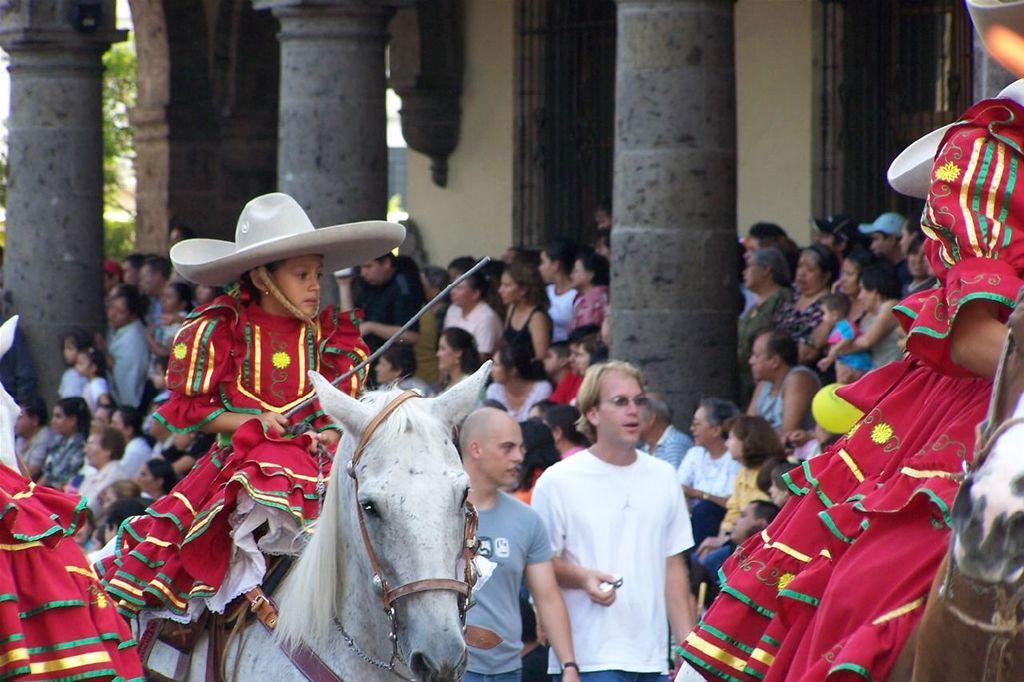Please provide a concise description of this image. In this image I see a child on a horse and in the background I see number of people and pillars and the wall. 